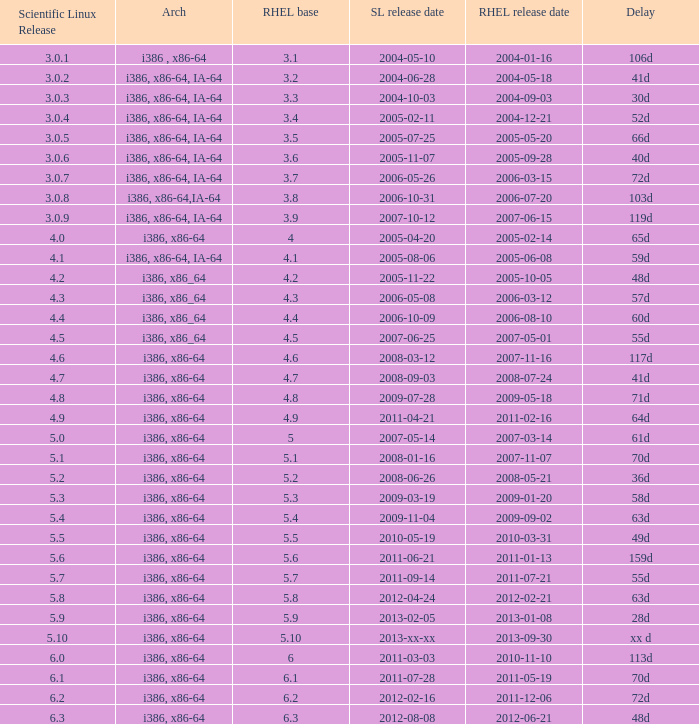Name the delay when scientific linux release is 5.10 Xx d. 